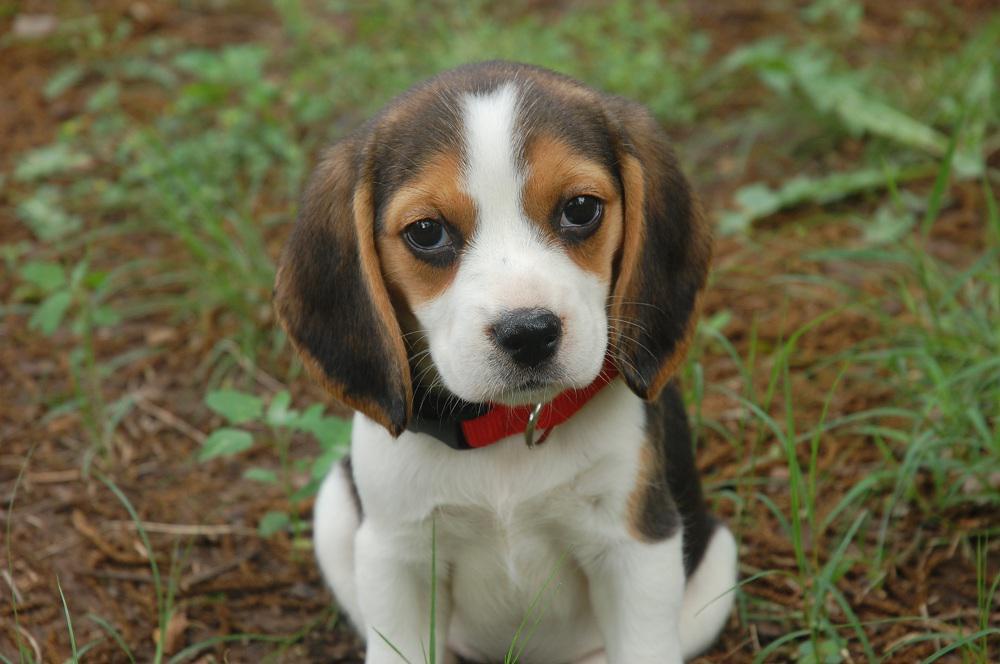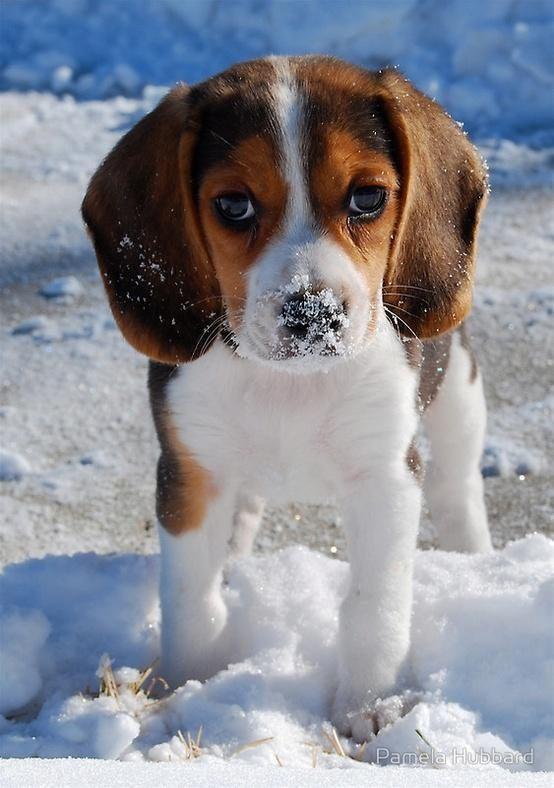The first image is the image on the left, the second image is the image on the right. Examine the images to the left and right. Is the description "The left image contains exactly two puppies." accurate? Answer yes or no. No. The first image is the image on the left, the second image is the image on the right. Assess this claim about the two images: "Two dogs pose together in the image on the left.". Correct or not? Answer yes or no. No. 